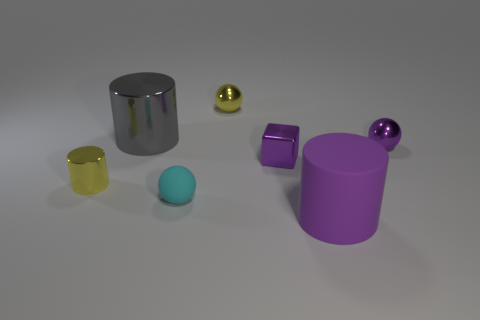Is there a large purple cylinder?
Keep it short and to the point. Yes. Is the number of small purple metal things that are right of the rubber cylinder greater than the number of small purple balls that are left of the big gray shiny cylinder?
Your response must be concise. Yes. What color is the tiny ball right of the big rubber object to the right of the cyan rubber thing?
Give a very brief answer. Purple. Is there a shiny ball that has the same color as the tiny rubber object?
Your response must be concise. No. There is a sphere right of the large object in front of the tiny metal thing on the right side of the matte cylinder; what size is it?
Keep it short and to the point. Small. There is a small cyan matte object; what shape is it?
Offer a very short reply. Sphere. The cylinder that is the same color as the small shiny cube is what size?
Make the answer very short. Large. There is a tiny metal object that is in front of the small purple block; what number of tiny yellow metal balls are in front of it?
Offer a very short reply. 0. How many other things are there of the same material as the yellow cylinder?
Make the answer very short. 4. Does the sphere that is behind the big shiny object have the same material as the tiny yellow thing that is left of the big gray object?
Offer a terse response. Yes. 